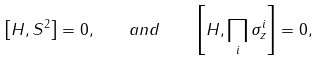Convert formula to latex. <formula><loc_0><loc_0><loc_500><loc_500>\left [ H , { S } ^ { 2 } \right ] = 0 , \quad a n d \quad \left [ H , \prod _ { i } \sigma _ { z } ^ { i } \right ] = 0 ,</formula> 